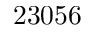<formula> <loc_0><loc_0><loc_500><loc_500>2 3 0 5 6</formula> 